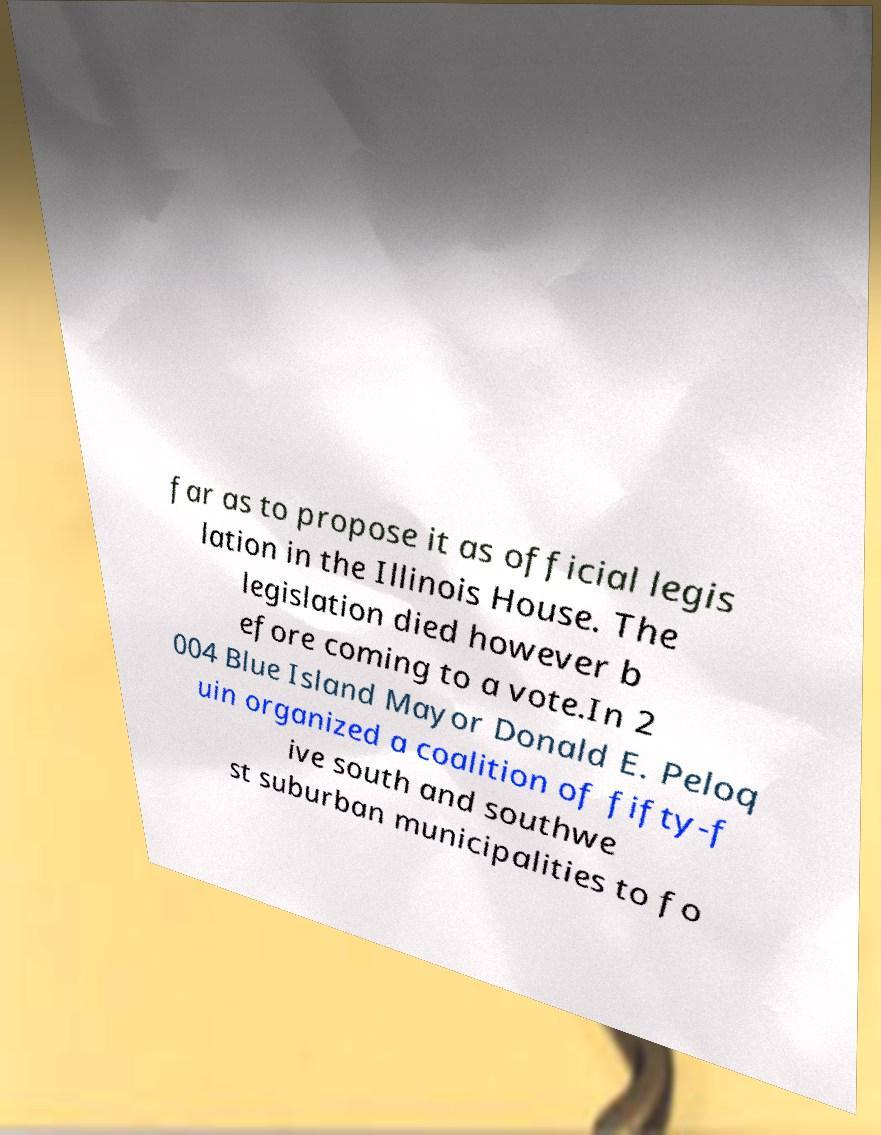Can you read and provide the text displayed in the image?This photo seems to have some interesting text. Can you extract and type it out for me? far as to propose it as official legis lation in the Illinois House. The legislation died however b efore coming to a vote.In 2 004 Blue Island Mayor Donald E. Peloq uin organized a coalition of fifty-f ive south and southwe st suburban municipalities to fo 